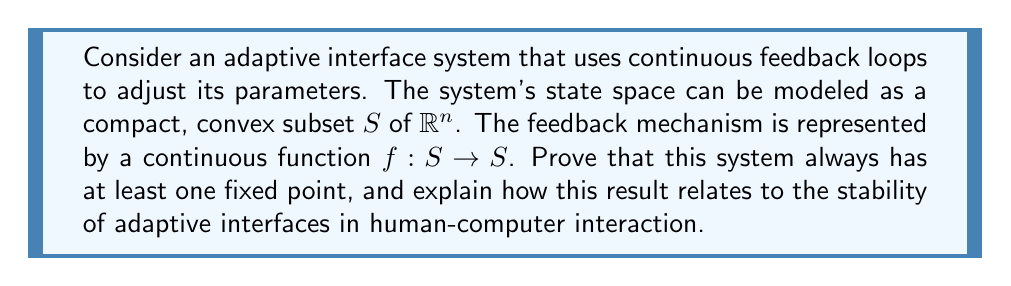Can you solve this math problem? To prove that the system always has at least one fixed point, we can apply Brouwer's fixed-point theorem. The proof follows these steps:

1. Identify the conditions for Brouwer's fixed-point theorem:
   - $S$ is a compact, convex subset of $\mathbb{R}^n$
   - $f: S \rightarrow S$ is a continuous function

2. Apply Brouwer's fixed-point theorem:
   Given that the conditions are met, Brouwer's theorem states that there exists at least one point $x \in S$ such that $f(x) = x$. This point is called a fixed point.

3. Interpretation in the context of adaptive interfaces:
   - The fixed point represents a stable state of the interface where the feedback loop does not cause further changes.
   - In affective computing and human-computer interaction, this could represent an optimal configuration of the interface that best suits the user's needs or emotional state.

4. Importance for adaptive interfaces:
   - The existence of a fixed point guarantees that the adaptive system will eventually reach a stable state, preventing endless oscillations or divergent behavior.
   - This stability is crucial for creating predictable and reliable user experiences in affective computing applications.

5. Limitations and considerations:
   - While the theorem guarantees the existence of a fixed point, it doesn't provide information about its uniqueness or how to find it.
   - In practice, adaptive interfaces may have multiple fixed points, representing different stable configurations.
   - The convergence rate to a fixed point is not addressed by the theorem and may be an important factor in the responsiveness of the adaptive interface.

6. Connection to affective computing research:
   - In affective computing, the fixed point could represent an emotional equilibrium state where the interface has successfully adapted to the user's affective state.
   - The continuous nature of the feedback loop aligns with the ongoing process of emotion recognition and adaptation in affective computing systems.

This result provides a theoretical foundation for the stability of adaptive interfaces in human-computer interaction, supporting the development of robust and responsive systems in affective computing applications.
Answer: The system always has at least one fixed point, guaranteed by Brouwer's fixed-point theorem, given that $S$ is a compact, convex subset of $\mathbb{R}^n$ and $f: S \rightarrow S$ is continuous. This fixed point represents a stable state in the adaptive interface, crucial for creating predictable and reliable user experiences in affective computing and human-computer interaction applications. 